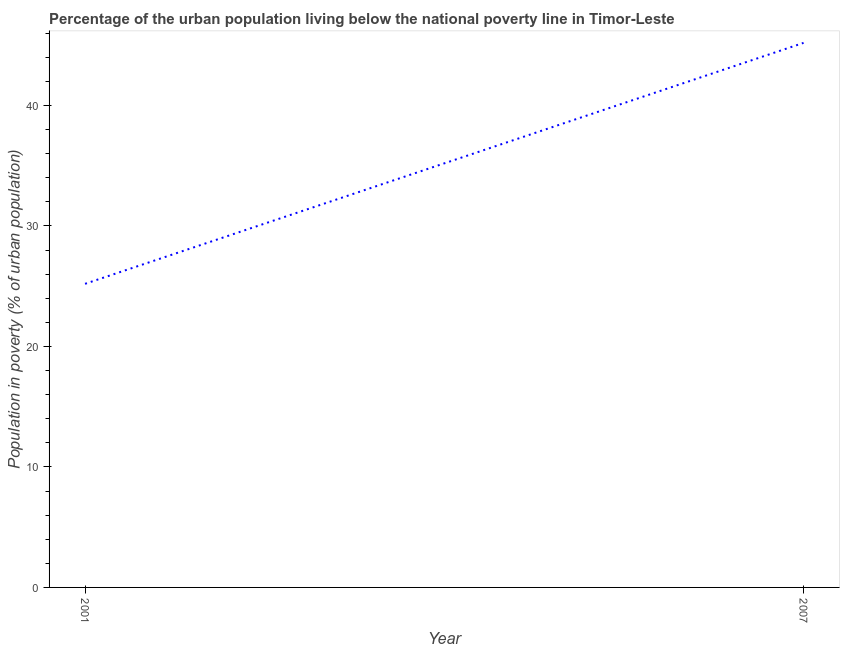What is the percentage of urban population living below poverty line in 2007?
Your response must be concise. 45.2. Across all years, what is the maximum percentage of urban population living below poverty line?
Your response must be concise. 45.2. Across all years, what is the minimum percentage of urban population living below poverty line?
Provide a short and direct response. 25.2. In which year was the percentage of urban population living below poverty line maximum?
Offer a very short reply. 2007. What is the sum of the percentage of urban population living below poverty line?
Make the answer very short. 70.4. What is the difference between the percentage of urban population living below poverty line in 2001 and 2007?
Make the answer very short. -20. What is the average percentage of urban population living below poverty line per year?
Your answer should be very brief. 35.2. What is the median percentage of urban population living below poverty line?
Ensure brevity in your answer.  35.2. In how many years, is the percentage of urban population living below poverty line greater than 12 %?
Offer a terse response. 2. Do a majority of the years between 2001 and 2007 (inclusive) have percentage of urban population living below poverty line greater than 32 %?
Make the answer very short. No. What is the ratio of the percentage of urban population living below poverty line in 2001 to that in 2007?
Provide a short and direct response. 0.56. In how many years, is the percentage of urban population living below poverty line greater than the average percentage of urban population living below poverty line taken over all years?
Ensure brevity in your answer.  1. How many lines are there?
Ensure brevity in your answer.  1. How many years are there in the graph?
Offer a very short reply. 2. What is the difference between two consecutive major ticks on the Y-axis?
Offer a very short reply. 10. Are the values on the major ticks of Y-axis written in scientific E-notation?
Make the answer very short. No. Does the graph contain grids?
Make the answer very short. No. What is the title of the graph?
Ensure brevity in your answer.  Percentage of the urban population living below the national poverty line in Timor-Leste. What is the label or title of the X-axis?
Offer a terse response. Year. What is the label or title of the Y-axis?
Keep it short and to the point. Population in poverty (% of urban population). What is the Population in poverty (% of urban population) of 2001?
Keep it short and to the point. 25.2. What is the Population in poverty (% of urban population) in 2007?
Offer a terse response. 45.2. What is the ratio of the Population in poverty (% of urban population) in 2001 to that in 2007?
Your answer should be compact. 0.56. 